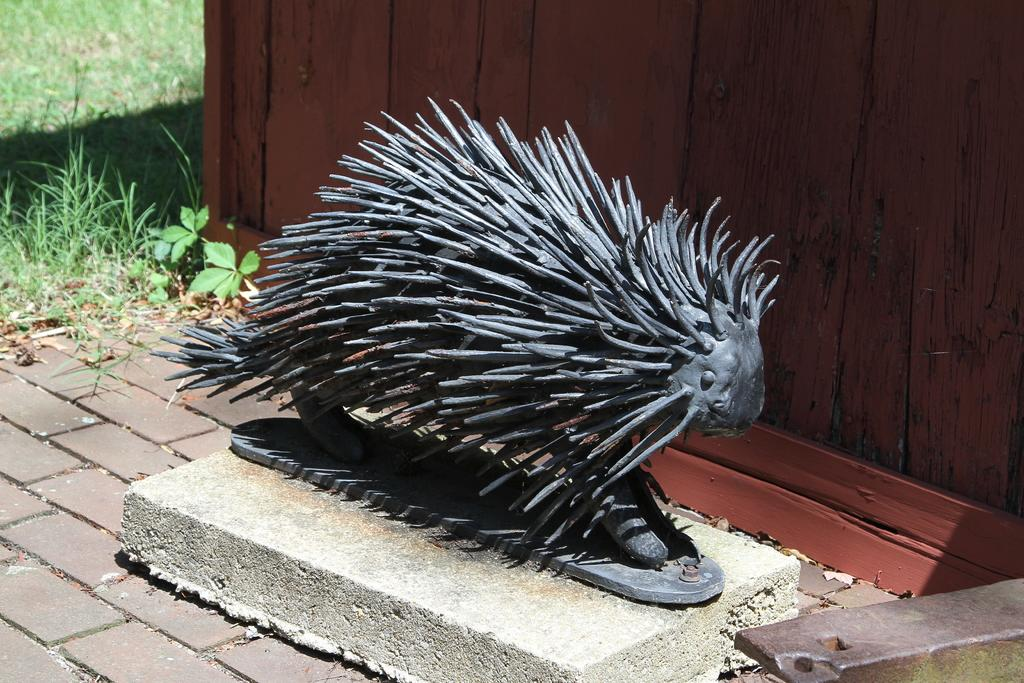What type of animal is the statue in the image modeled after? The statue in the image is in the shape of a porcupine. What material is the statue made of? The statue is made of wood. What can be seen on the right side of the image? There is a wooden wall on the right side of the image. What type of vegetation is on the left side of the image? There is grass on the left side of the image. What time does the hen arrive in the image? There is no hen present in the image, so it is not possible to determine when it might arrive. 